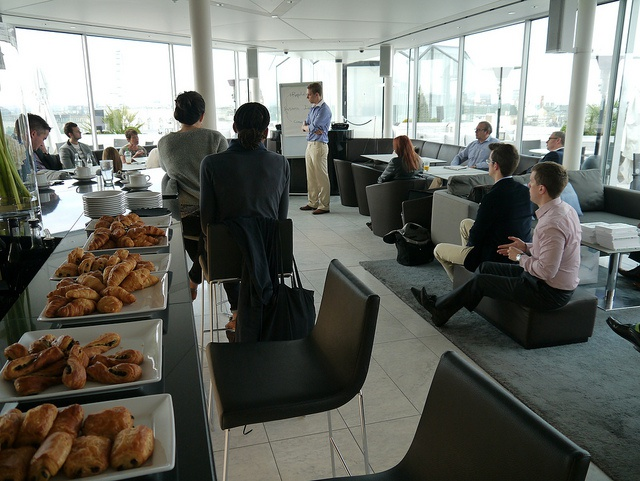Describe the objects in this image and their specific colors. I can see chair in darkgray, black, and gray tones, chair in darkgray, black, gray, and purple tones, people in darkgray, black, and gray tones, people in darkgray, black, gray, and purple tones, and people in darkgray, black, and gray tones in this image. 